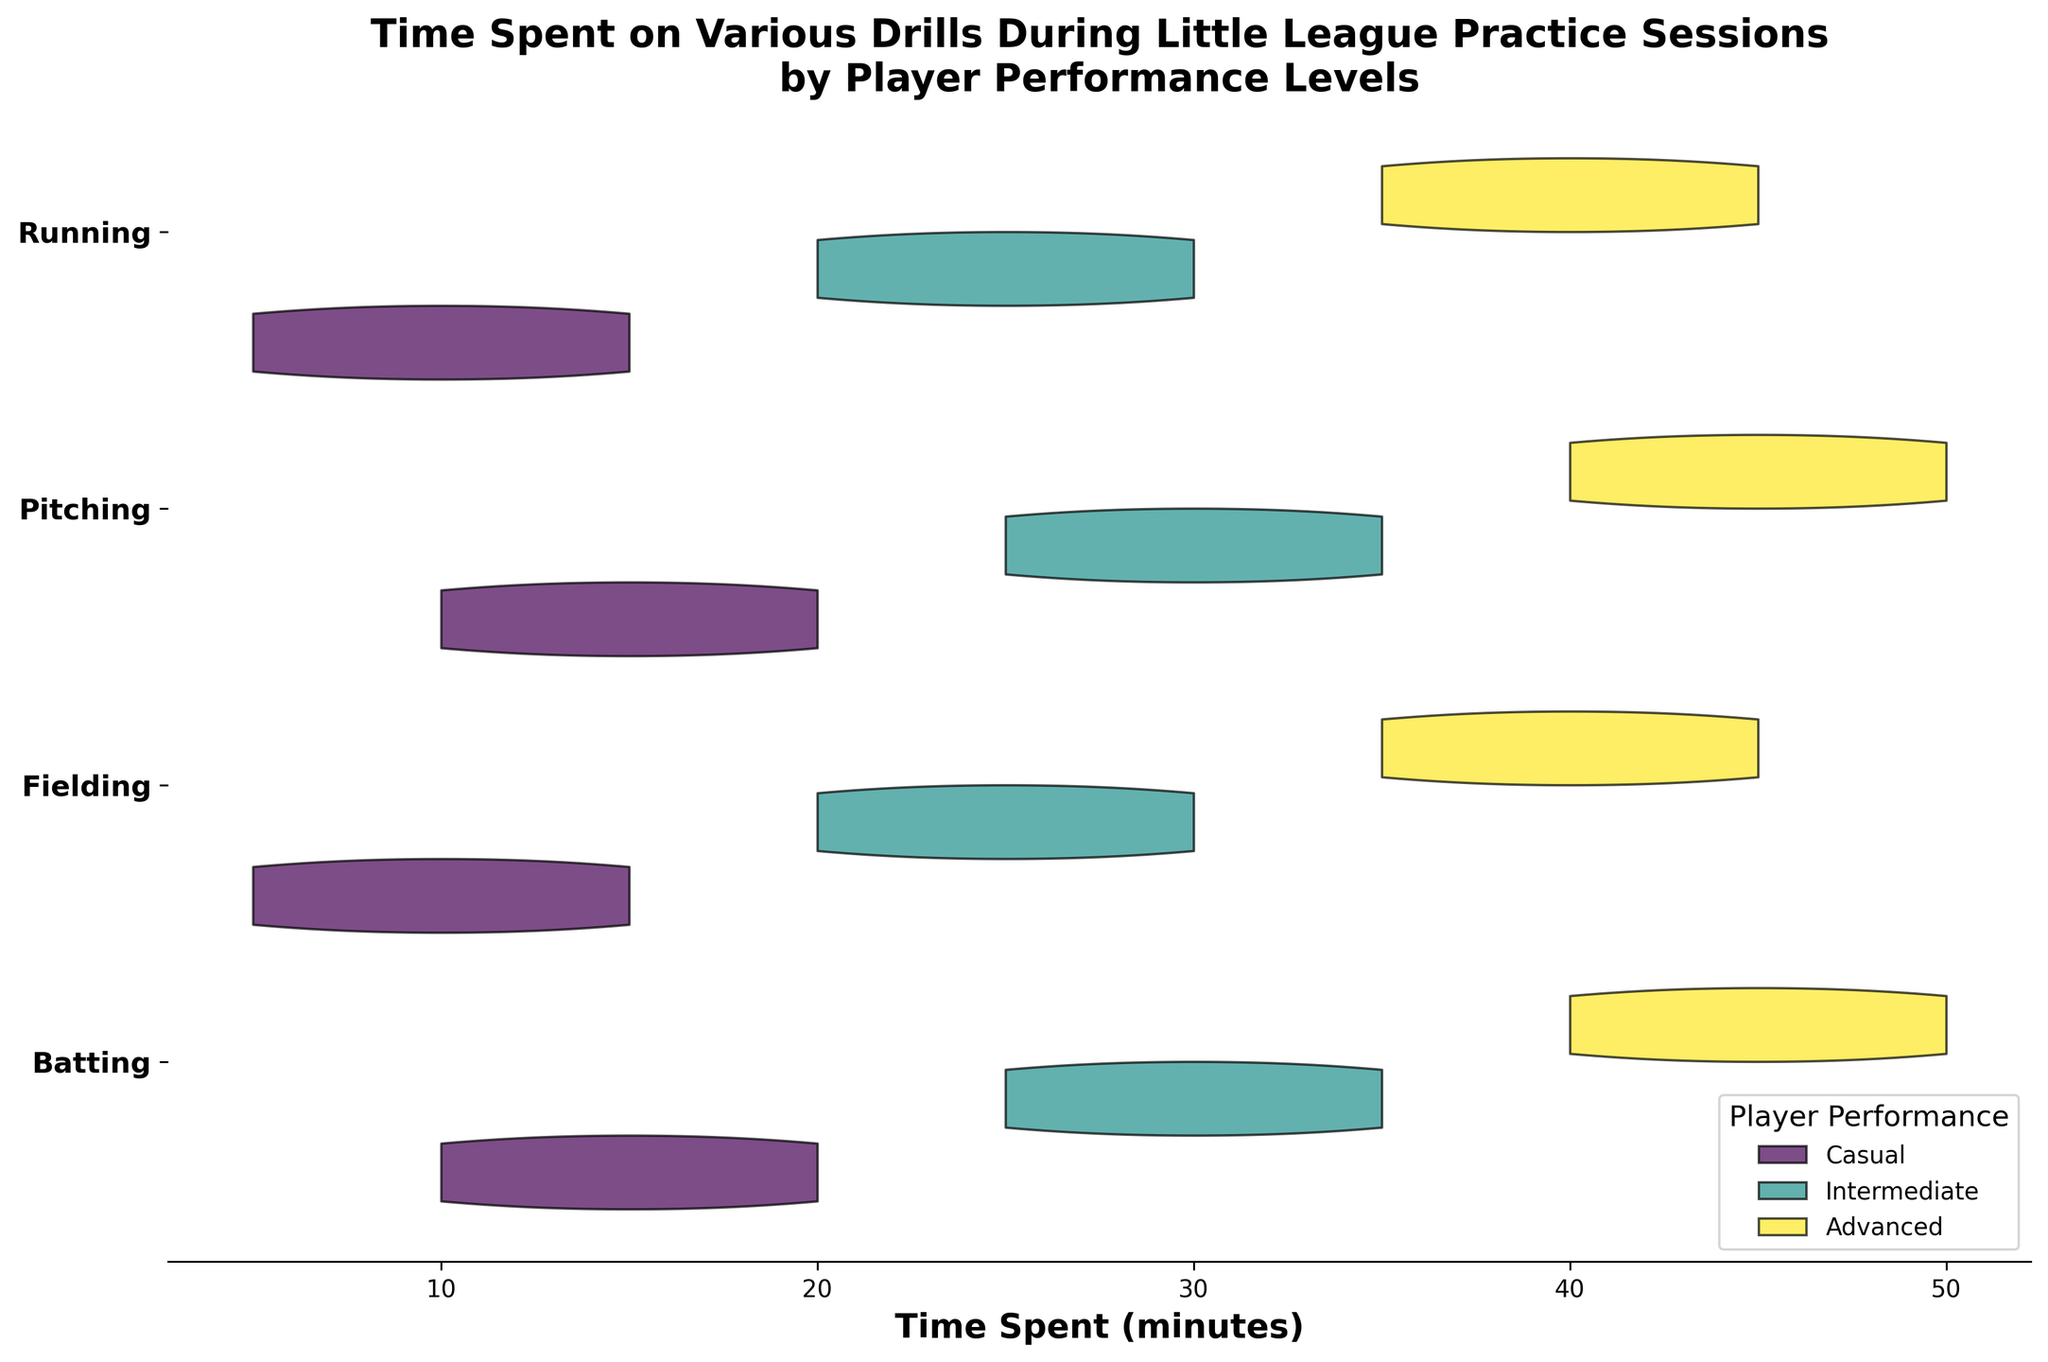Which player performance level spends the most time on Batting? The Advanced player performance level spends the most time on Batting since their range on the horizontal axis is the highest and spans from 40 to 50 minutes.
Answer: Advanced What is the maximum amount of time spent on Running for Casual players? Observing the portions of the violin chart for Running under Casual, the maximum point on the horizontal axis is 15 minutes.
Answer: 15 minutes Out of all the drills, which one has the largest variety in time spent for Intermediate players? Examining the horizontal width of the Intermediate violins across drills, the largest range appears for Pitching, spanning from 25 to 35 minutes.
Answer: Pitching Which drill shows the least time variation across all performance levels? By comparing the width of the violins for each drill, Fielding shows the smallest ranges across Casual, Intermediate, and Advanced levels.
Answer: Fielding What is the title of the figure? The title of the figure is "Time Spent on Various Drills During Little League Practice Sessions by Player Performance Levels."
Answer: Time Spent on Various Drills During Little League Practice Sessions by Player Performance Levels Where is the legend located in this figure? The legend is located at the lower right of the figure and it contains Player Performance levels.
Answer: Lower right Do Intermediate players spend more time on Fielding or Batting? Checking the violin charts for Intermediate players, the Fielding chart ranges from 20 to 30 minutes, while the Batting chart ranges from 25 to 35 minutes, indicating more time is spent on Batting.
Answer: Batting What is the minimum time spent on Pitching by Advanced players? Observing the minimum point on the Pitching violin for Advanced players, the smallest time spent is 40 minutes.
Answer: 40 minutes Which Performance level is represented by the widest range in time spent on any drill? By comparing ranges across all drills for each performance level, the widest range belongs to Advanced players in Batting from 40 to 50 minutes.
Answer: Advanced 